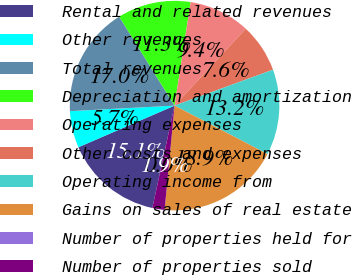Convert chart to OTSL. <chart><loc_0><loc_0><loc_500><loc_500><pie_chart><fcel>Rental and related revenues<fcel>Other revenues<fcel>Total revenues<fcel>Depreciation and amortization<fcel>Operating expenses<fcel>Other costs and expenses<fcel>Operating income from<fcel>Gains on sales of real estate<fcel>Number of properties held for<fcel>Number of properties sold<nl><fcel>15.09%<fcel>5.66%<fcel>16.98%<fcel>11.32%<fcel>9.43%<fcel>7.55%<fcel>13.21%<fcel>18.87%<fcel>0.0%<fcel>1.89%<nl></chart> 